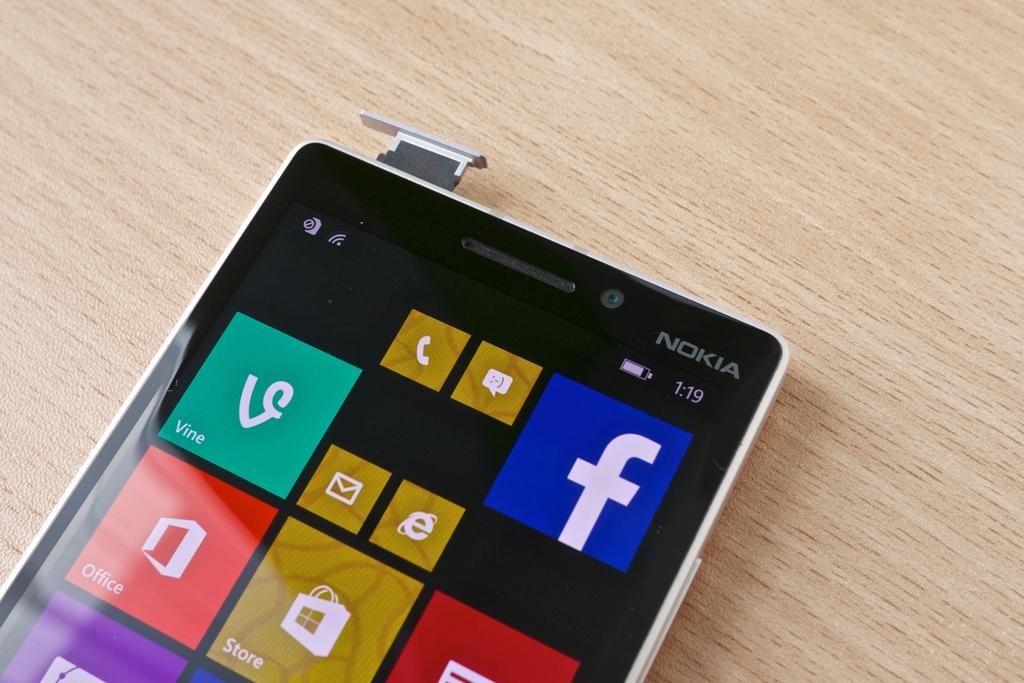<image>
Share a concise interpretation of the image provided. A Nokia mobile device sits on a lightly colored wooden table at 1:19. 